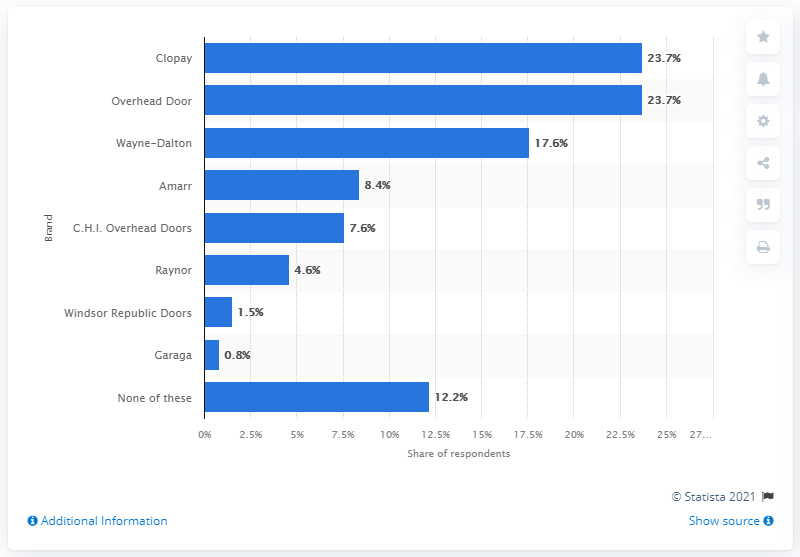What brand of garage doors did 17.6 percent of respondents use the most? The chart indicates that 17.6 percent of respondents use Wayne-Dalton garage doors the most, making it the second most popular brand after Clopay which is used by 23.7 percent of respondents. 